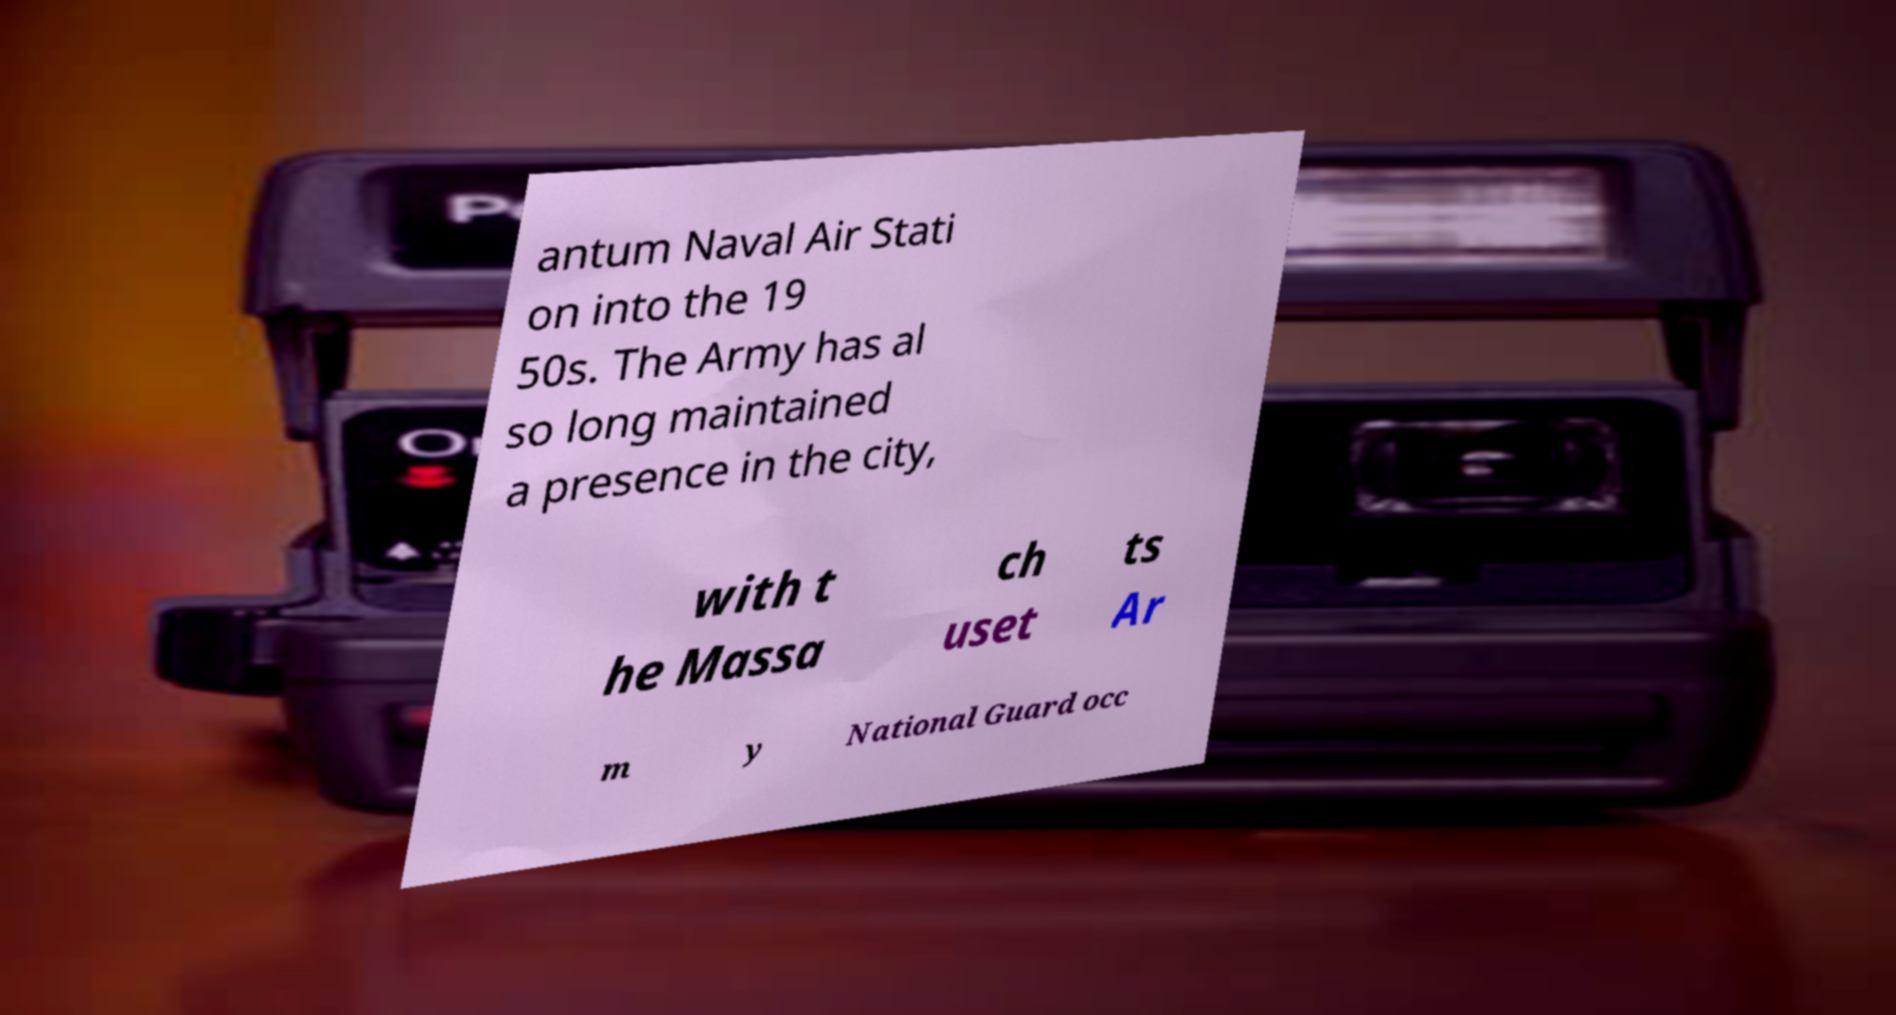Please identify and transcribe the text found in this image. antum Naval Air Stati on into the 19 50s. The Army has al so long maintained a presence in the city, with t he Massa ch uset ts Ar m y National Guard occ 